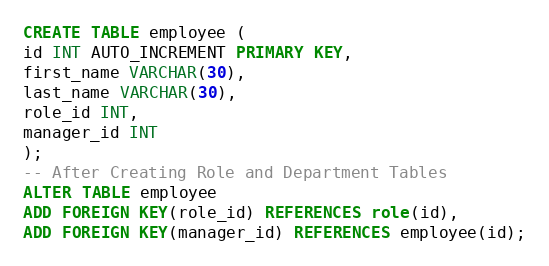Convert code to text. <code><loc_0><loc_0><loc_500><loc_500><_SQL_>CREATE TABLE employee (
id INT AUTO_INCREMENT PRIMARY KEY,
first_name VARCHAR(30),
last_name VARCHAR(30),
role_id INT,
manager_id INT
);
-- After Creating Role and Department Tables
ALTER TABLE employee
ADD FOREIGN KEY(role_id) REFERENCES role(id),
ADD FOREIGN KEY(manager_id) REFERENCES employee(id);</code> 